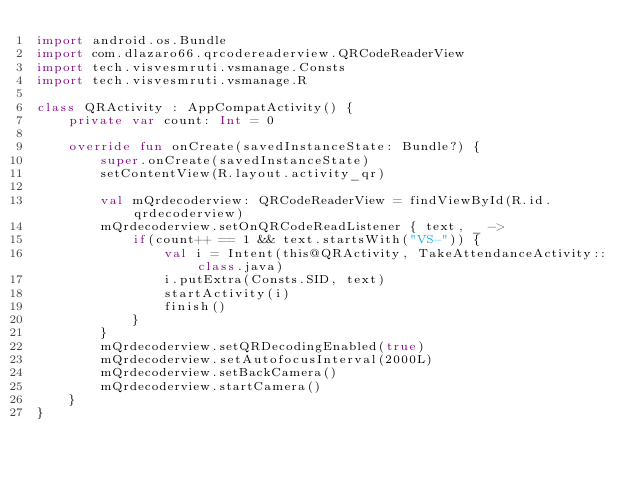<code> <loc_0><loc_0><loc_500><loc_500><_Kotlin_>import android.os.Bundle
import com.dlazaro66.qrcodereaderview.QRCodeReaderView
import tech.visvesmruti.vsmanage.Consts
import tech.visvesmruti.vsmanage.R

class QRActivity : AppCompatActivity() {
    private var count: Int = 0

    override fun onCreate(savedInstanceState: Bundle?) {
        super.onCreate(savedInstanceState)
        setContentView(R.layout.activity_qr)

        val mQrdecoderview: QRCodeReaderView = findViewById(R.id.qrdecoderview)
        mQrdecoderview.setOnQRCodeReadListener { text, _ ->
            if(count++ == 1 && text.startsWith("VS-")) {
                val i = Intent(this@QRActivity, TakeAttendanceActivity::class.java)
                i.putExtra(Consts.SID, text)
                startActivity(i)
                finish()
            }
        }
        mQrdecoderview.setQRDecodingEnabled(true)
        mQrdecoderview.setAutofocusInterval(2000L)
        mQrdecoderview.setBackCamera()
        mQrdecoderview.startCamera()
    }
}
</code> 